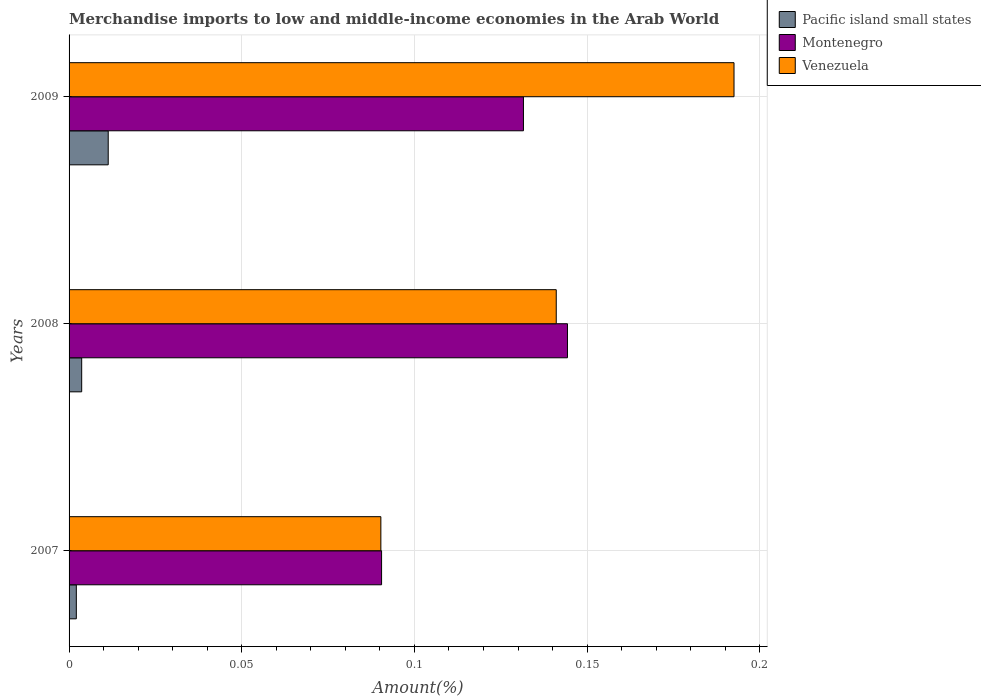How many groups of bars are there?
Give a very brief answer. 3. Are the number of bars on each tick of the Y-axis equal?
Offer a terse response. Yes. How many bars are there on the 2nd tick from the bottom?
Your answer should be very brief. 3. In how many cases, is the number of bars for a given year not equal to the number of legend labels?
Offer a terse response. 0. What is the percentage of amount earned from merchandise imports in Montenegro in 2007?
Make the answer very short. 0.09. Across all years, what is the maximum percentage of amount earned from merchandise imports in Montenegro?
Keep it short and to the point. 0.14. Across all years, what is the minimum percentage of amount earned from merchandise imports in Venezuela?
Offer a very short reply. 0.09. What is the total percentage of amount earned from merchandise imports in Venezuela in the graph?
Make the answer very short. 0.42. What is the difference between the percentage of amount earned from merchandise imports in Montenegro in 2007 and that in 2008?
Provide a succinct answer. -0.05. What is the difference between the percentage of amount earned from merchandise imports in Venezuela in 2008 and the percentage of amount earned from merchandise imports in Pacific island small states in 2007?
Give a very brief answer. 0.14. What is the average percentage of amount earned from merchandise imports in Venezuela per year?
Keep it short and to the point. 0.14. In the year 2007, what is the difference between the percentage of amount earned from merchandise imports in Venezuela and percentage of amount earned from merchandise imports in Pacific island small states?
Offer a very short reply. 0.09. In how many years, is the percentage of amount earned from merchandise imports in Pacific island small states greater than 0.11 %?
Ensure brevity in your answer.  0. What is the ratio of the percentage of amount earned from merchandise imports in Venezuela in 2007 to that in 2008?
Offer a very short reply. 0.64. Is the percentage of amount earned from merchandise imports in Venezuela in 2007 less than that in 2009?
Make the answer very short. Yes. Is the difference between the percentage of amount earned from merchandise imports in Venezuela in 2008 and 2009 greater than the difference between the percentage of amount earned from merchandise imports in Pacific island small states in 2008 and 2009?
Provide a short and direct response. No. What is the difference between the highest and the second highest percentage of amount earned from merchandise imports in Montenegro?
Your answer should be very brief. 0.01. What is the difference between the highest and the lowest percentage of amount earned from merchandise imports in Montenegro?
Offer a very short reply. 0.05. Is the sum of the percentage of amount earned from merchandise imports in Pacific island small states in 2007 and 2009 greater than the maximum percentage of amount earned from merchandise imports in Montenegro across all years?
Offer a very short reply. No. What does the 2nd bar from the top in 2008 represents?
Provide a short and direct response. Montenegro. What does the 3rd bar from the bottom in 2008 represents?
Offer a very short reply. Venezuela. Is it the case that in every year, the sum of the percentage of amount earned from merchandise imports in Pacific island small states and percentage of amount earned from merchandise imports in Venezuela is greater than the percentage of amount earned from merchandise imports in Montenegro?
Ensure brevity in your answer.  Yes. How many years are there in the graph?
Keep it short and to the point. 3. What is the difference between two consecutive major ticks on the X-axis?
Provide a short and direct response. 0.05. Does the graph contain grids?
Make the answer very short. Yes. Where does the legend appear in the graph?
Make the answer very short. Top right. How are the legend labels stacked?
Your answer should be compact. Vertical. What is the title of the graph?
Offer a very short reply. Merchandise imports to low and middle-income economies in the Arab World. What is the label or title of the X-axis?
Make the answer very short. Amount(%). What is the Amount(%) of Pacific island small states in 2007?
Keep it short and to the point. 0. What is the Amount(%) of Montenegro in 2007?
Provide a short and direct response. 0.09. What is the Amount(%) of Venezuela in 2007?
Provide a short and direct response. 0.09. What is the Amount(%) of Pacific island small states in 2008?
Offer a very short reply. 0. What is the Amount(%) in Montenegro in 2008?
Provide a succinct answer. 0.14. What is the Amount(%) of Venezuela in 2008?
Your response must be concise. 0.14. What is the Amount(%) in Pacific island small states in 2009?
Keep it short and to the point. 0.01. What is the Amount(%) of Montenegro in 2009?
Provide a succinct answer. 0.13. What is the Amount(%) of Venezuela in 2009?
Ensure brevity in your answer.  0.19. Across all years, what is the maximum Amount(%) in Pacific island small states?
Your answer should be very brief. 0.01. Across all years, what is the maximum Amount(%) of Montenegro?
Provide a short and direct response. 0.14. Across all years, what is the maximum Amount(%) in Venezuela?
Give a very brief answer. 0.19. Across all years, what is the minimum Amount(%) in Pacific island small states?
Provide a short and direct response. 0. Across all years, what is the minimum Amount(%) of Montenegro?
Provide a succinct answer. 0.09. Across all years, what is the minimum Amount(%) in Venezuela?
Your response must be concise. 0.09. What is the total Amount(%) of Pacific island small states in the graph?
Your answer should be compact. 0.02. What is the total Amount(%) in Montenegro in the graph?
Your answer should be very brief. 0.37. What is the total Amount(%) of Venezuela in the graph?
Make the answer very short. 0.42. What is the difference between the Amount(%) in Pacific island small states in 2007 and that in 2008?
Offer a very short reply. -0. What is the difference between the Amount(%) in Montenegro in 2007 and that in 2008?
Your answer should be compact. -0.05. What is the difference between the Amount(%) in Venezuela in 2007 and that in 2008?
Give a very brief answer. -0.05. What is the difference between the Amount(%) of Pacific island small states in 2007 and that in 2009?
Keep it short and to the point. -0.01. What is the difference between the Amount(%) of Montenegro in 2007 and that in 2009?
Your answer should be compact. -0.04. What is the difference between the Amount(%) in Venezuela in 2007 and that in 2009?
Your answer should be very brief. -0.1. What is the difference between the Amount(%) in Pacific island small states in 2008 and that in 2009?
Offer a very short reply. -0.01. What is the difference between the Amount(%) in Montenegro in 2008 and that in 2009?
Your response must be concise. 0.01. What is the difference between the Amount(%) in Venezuela in 2008 and that in 2009?
Your response must be concise. -0.05. What is the difference between the Amount(%) in Pacific island small states in 2007 and the Amount(%) in Montenegro in 2008?
Make the answer very short. -0.14. What is the difference between the Amount(%) of Pacific island small states in 2007 and the Amount(%) of Venezuela in 2008?
Provide a short and direct response. -0.14. What is the difference between the Amount(%) in Montenegro in 2007 and the Amount(%) in Venezuela in 2008?
Your answer should be compact. -0.05. What is the difference between the Amount(%) in Pacific island small states in 2007 and the Amount(%) in Montenegro in 2009?
Your response must be concise. -0.13. What is the difference between the Amount(%) in Pacific island small states in 2007 and the Amount(%) in Venezuela in 2009?
Offer a terse response. -0.19. What is the difference between the Amount(%) of Montenegro in 2007 and the Amount(%) of Venezuela in 2009?
Your answer should be very brief. -0.1. What is the difference between the Amount(%) in Pacific island small states in 2008 and the Amount(%) in Montenegro in 2009?
Offer a very short reply. -0.13. What is the difference between the Amount(%) in Pacific island small states in 2008 and the Amount(%) in Venezuela in 2009?
Your response must be concise. -0.19. What is the difference between the Amount(%) of Montenegro in 2008 and the Amount(%) of Venezuela in 2009?
Offer a very short reply. -0.05. What is the average Amount(%) of Pacific island small states per year?
Provide a succinct answer. 0.01. What is the average Amount(%) in Montenegro per year?
Make the answer very short. 0.12. What is the average Amount(%) of Venezuela per year?
Your answer should be very brief. 0.14. In the year 2007, what is the difference between the Amount(%) of Pacific island small states and Amount(%) of Montenegro?
Provide a succinct answer. -0.09. In the year 2007, what is the difference between the Amount(%) of Pacific island small states and Amount(%) of Venezuela?
Provide a short and direct response. -0.09. In the year 2007, what is the difference between the Amount(%) in Montenegro and Amount(%) in Venezuela?
Ensure brevity in your answer.  0. In the year 2008, what is the difference between the Amount(%) in Pacific island small states and Amount(%) in Montenegro?
Offer a very short reply. -0.14. In the year 2008, what is the difference between the Amount(%) in Pacific island small states and Amount(%) in Venezuela?
Provide a short and direct response. -0.14. In the year 2008, what is the difference between the Amount(%) of Montenegro and Amount(%) of Venezuela?
Your response must be concise. 0. In the year 2009, what is the difference between the Amount(%) in Pacific island small states and Amount(%) in Montenegro?
Offer a terse response. -0.12. In the year 2009, what is the difference between the Amount(%) of Pacific island small states and Amount(%) of Venezuela?
Give a very brief answer. -0.18. In the year 2009, what is the difference between the Amount(%) in Montenegro and Amount(%) in Venezuela?
Offer a terse response. -0.06. What is the ratio of the Amount(%) in Pacific island small states in 2007 to that in 2008?
Ensure brevity in your answer.  0.57. What is the ratio of the Amount(%) in Montenegro in 2007 to that in 2008?
Ensure brevity in your answer.  0.63. What is the ratio of the Amount(%) of Venezuela in 2007 to that in 2008?
Keep it short and to the point. 0.64. What is the ratio of the Amount(%) of Pacific island small states in 2007 to that in 2009?
Keep it short and to the point. 0.19. What is the ratio of the Amount(%) in Montenegro in 2007 to that in 2009?
Make the answer very short. 0.69. What is the ratio of the Amount(%) in Venezuela in 2007 to that in 2009?
Your answer should be very brief. 0.47. What is the ratio of the Amount(%) of Pacific island small states in 2008 to that in 2009?
Provide a succinct answer. 0.32. What is the ratio of the Amount(%) of Montenegro in 2008 to that in 2009?
Your answer should be compact. 1.1. What is the ratio of the Amount(%) of Venezuela in 2008 to that in 2009?
Keep it short and to the point. 0.73. What is the difference between the highest and the second highest Amount(%) in Pacific island small states?
Ensure brevity in your answer.  0.01. What is the difference between the highest and the second highest Amount(%) in Montenegro?
Ensure brevity in your answer.  0.01. What is the difference between the highest and the second highest Amount(%) of Venezuela?
Your answer should be very brief. 0.05. What is the difference between the highest and the lowest Amount(%) of Pacific island small states?
Your answer should be very brief. 0.01. What is the difference between the highest and the lowest Amount(%) of Montenegro?
Your response must be concise. 0.05. What is the difference between the highest and the lowest Amount(%) of Venezuela?
Give a very brief answer. 0.1. 